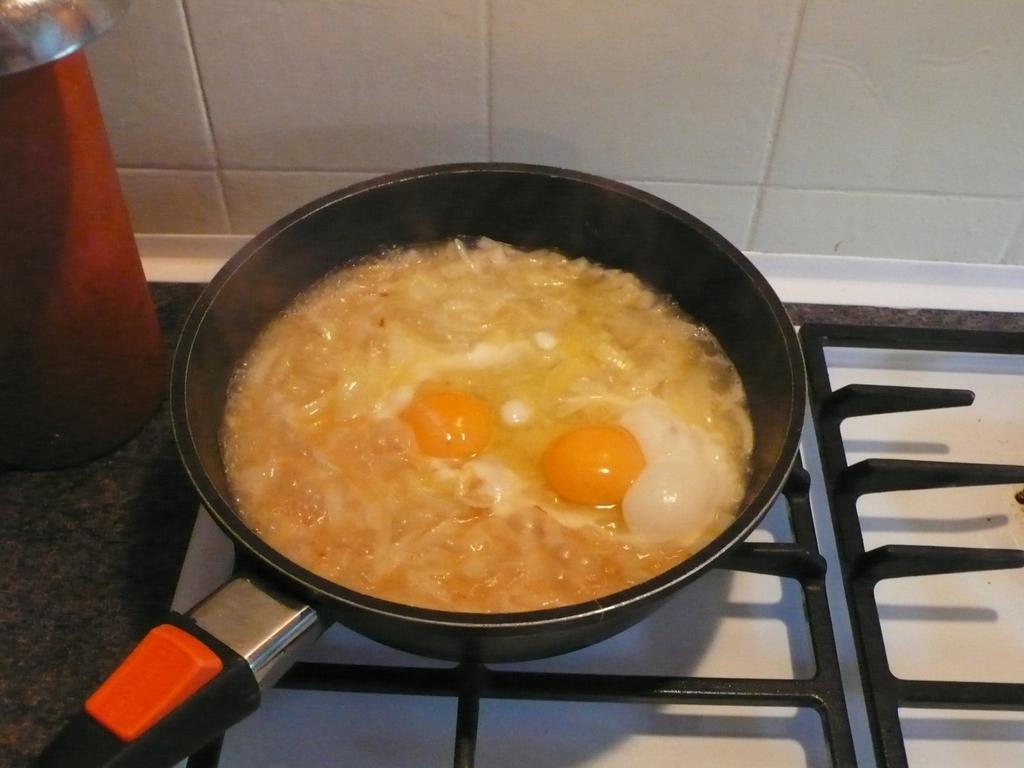How would you summarize this image in a sentence or two? In this image we can see a pan, in pan some eggs and onion are there. To the left side of the image one red color thing is present. Bottom of the image stove is there. 